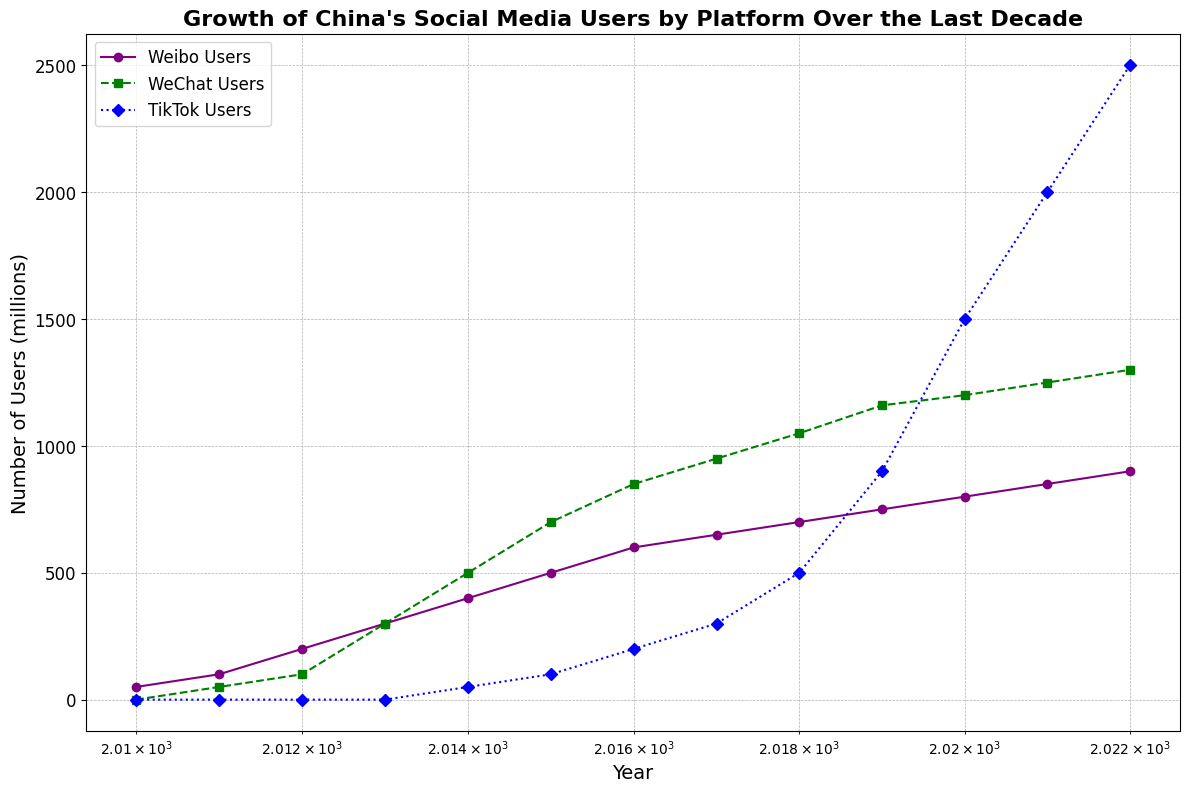How does the growth of WeChat users from 2011 to 2014 compare to the growth of Weibo users during the same period? From the year 2011 to 2014, WeChat users grew from 50 million to 500 million, a difference of 450 million. During the same period, Weibo users grew from 100 million to 400 million, a difference of 300 million. Therefore, WeChat users had a greater increase compared to Weibo users.
Answer: WeChat grew by 450 million, Weibo by 300 million Between what years did TikTok users experience the most significant growth? By examining the data points in the figure, TikTok users grew from 0 in 2014 to 2500 million in 2022. The largest growth occurred between 2019 and 2020, where the users increased from 900 million to 1500 million, a growth of 600 million users.
Answer: 2019 to 2020 Which social media platform had the highest number of users in 2022? By observing the final data points for 2022, WeChat has 1300 million users, Weibo has 900 million users, and TikTok has 2500 million users. TikTok user numbers are the highest.
Answer: TikTok What was the user growth trend for WeChat from 2013 to 2017, and how did it compare to Weibo during the same period? From 2013 to 2017, WeChat users increased from 300 million to 950 million, an increase of 650 million. Meanwhile, Weibo users grew from 300 million to 650 million, a 350 million increase during the same period. Thus, WeChat exhibited a more pronounced growth than Weibo.
Answer: WeChat grew by 650 million; Weibo grew by 350 million On the log scale of the x-axis, at which year marks do the two platforms, Weibo and TikTok, first exceed 800 million users? By examining the log-scaled x-axis, Weibo first exceeds 800 million users in 2020, and TikTok first exceeds 800 million users in 2019.
Answer: Weibo in 2020, TikTok in 2019 What is the difference in the number of WeChat users between the years 2016 and 2021? In 2016, WeChat had 850 million users, and in 2021, it had 1250 million users. The difference is 1250 million - 850 million = 400 million users.
Answer: 400 million users How did the use of Weibo and TikTok evolve from 2016 to 2020, and what was the absolute difference in user numbers for both platforms in 2020? From 2016 to 2020, Weibo users increased from 600 million to 800 million, a growth of 200 million users. In the same period, TikTok users went from 200 million to 1500 million, a growth of 1300 million users. The absolute difference in 2020 is 1500 million - 800 million = 700 million users.
Answer: 700 million users 